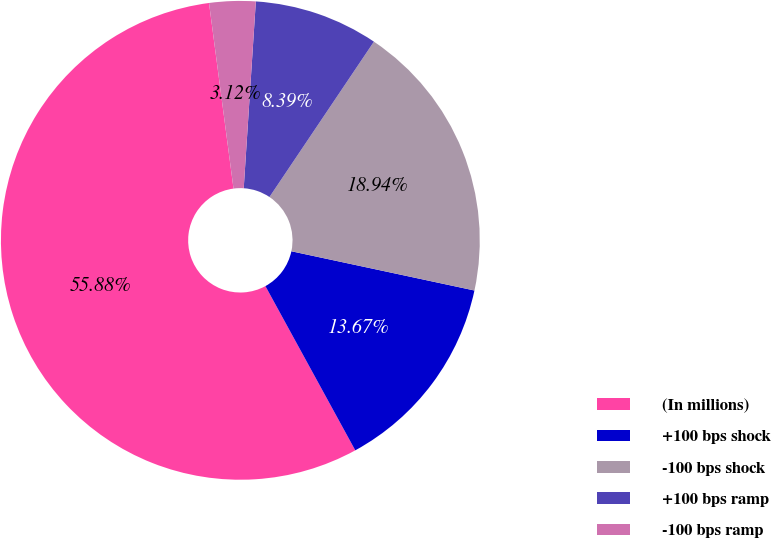Convert chart. <chart><loc_0><loc_0><loc_500><loc_500><pie_chart><fcel>(In millions)<fcel>+100 bps shock<fcel>-100 bps shock<fcel>+100 bps ramp<fcel>-100 bps ramp<nl><fcel>55.88%<fcel>13.67%<fcel>18.94%<fcel>8.39%<fcel>3.12%<nl></chart> 